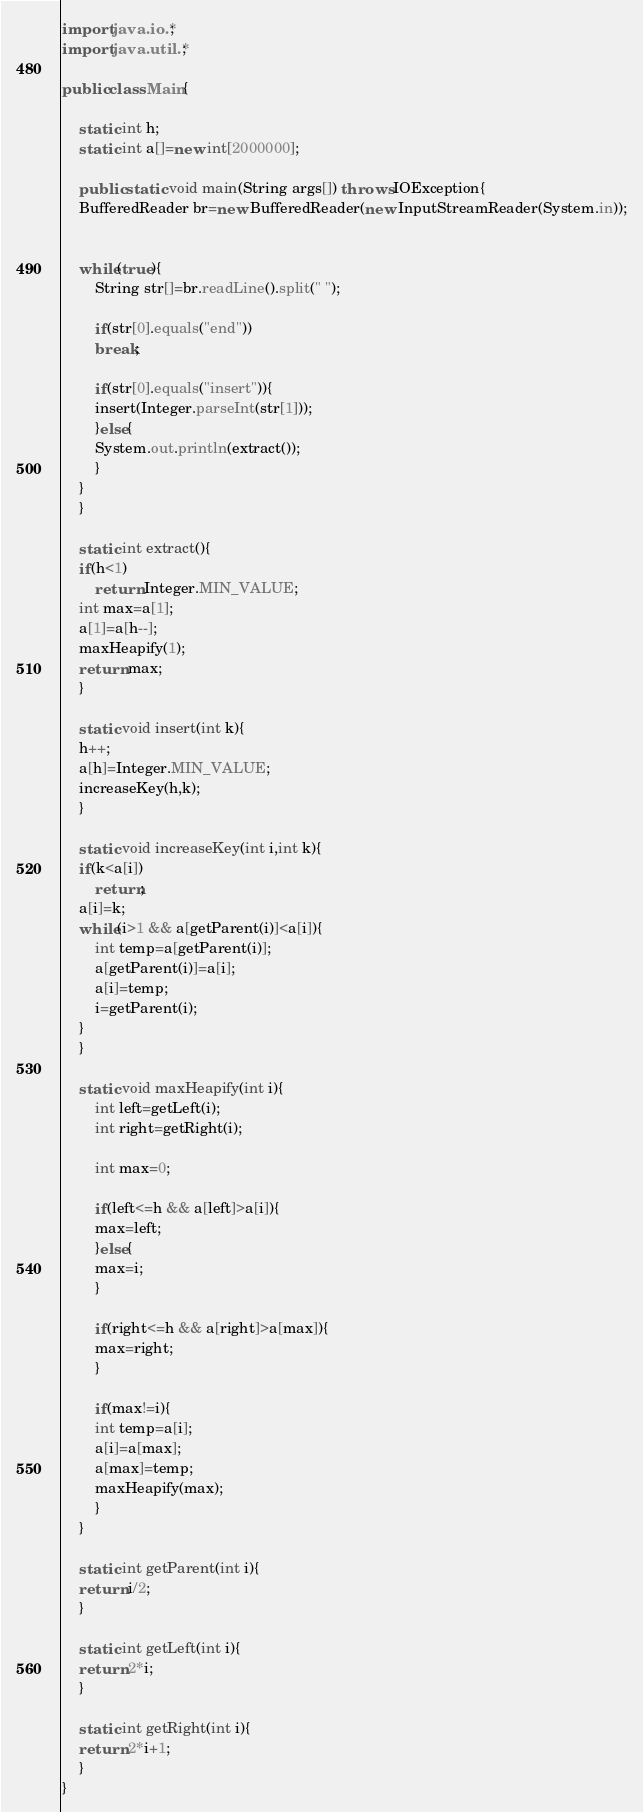Convert code to text. <code><loc_0><loc_0><loc_500><loc_500><_Java_>import java.io.*;
import java.util.*;

public class Main{

    static int h;
    static int a[]=new int[2000000];
    
    public static void main(String args[]) throws IOException{
	BufferedReader br=new BufferedReader(new InputStreamReader(System.in));

	
	while(true){
	    String str[]=br.readLine().split(" ");

	    if(str[0].equals("end"))
		break;

	    if(str[0].equals("insert")){
		insert(Integer.parseInt(str[1]));
	    }else{
		System.out.println(extract());
	    }
	}
    }

    static int extract(){
	if(h<1)
	    return Integer.MIN_VALUE;
	int max=a[1];
	a[1]=a[h--];
	maxHeapify(1);
	return max;
    }

    static void insert(int k){
	h++;
	a[h]=Integer.MIN_VALUE;
	increaseKey(h,k);
    }

    static void increaseKey(int i,int k){
	if(k<a[i])
	    return;
	a[i]=k;
	while(i>1 && a[getParent(i)]<a[i]){
	    int temp=a[getParent(i)];
	    a[getParent(i)]=a[i];
	    a[i]=temp;
	    i=getParent(i);
	}
    }

    static void maxHeapify(int i){
	    int left=getLeft(i);
	    int right=getRight(i);

	    int max=0;

	    if(left<=h && a[left]>a[i]){
		max=left;
	    }else{
		max=i;
	    }

	    if(right<=h && a[right]>a[max]){
		max=right;
	    }

	    if(max!=i){
		int temp=a[i];
		a[i]=a[max];
		a[max]=temp;
		maxHeapify(max);	
	    }
    }
    
    static int getParent(int i){
	return i/2;
    }

    static int getLeft(int i){
	return 2*i;
    }

    static int getRight(int i){
	return 2*i+1;
    }
}

</code> 